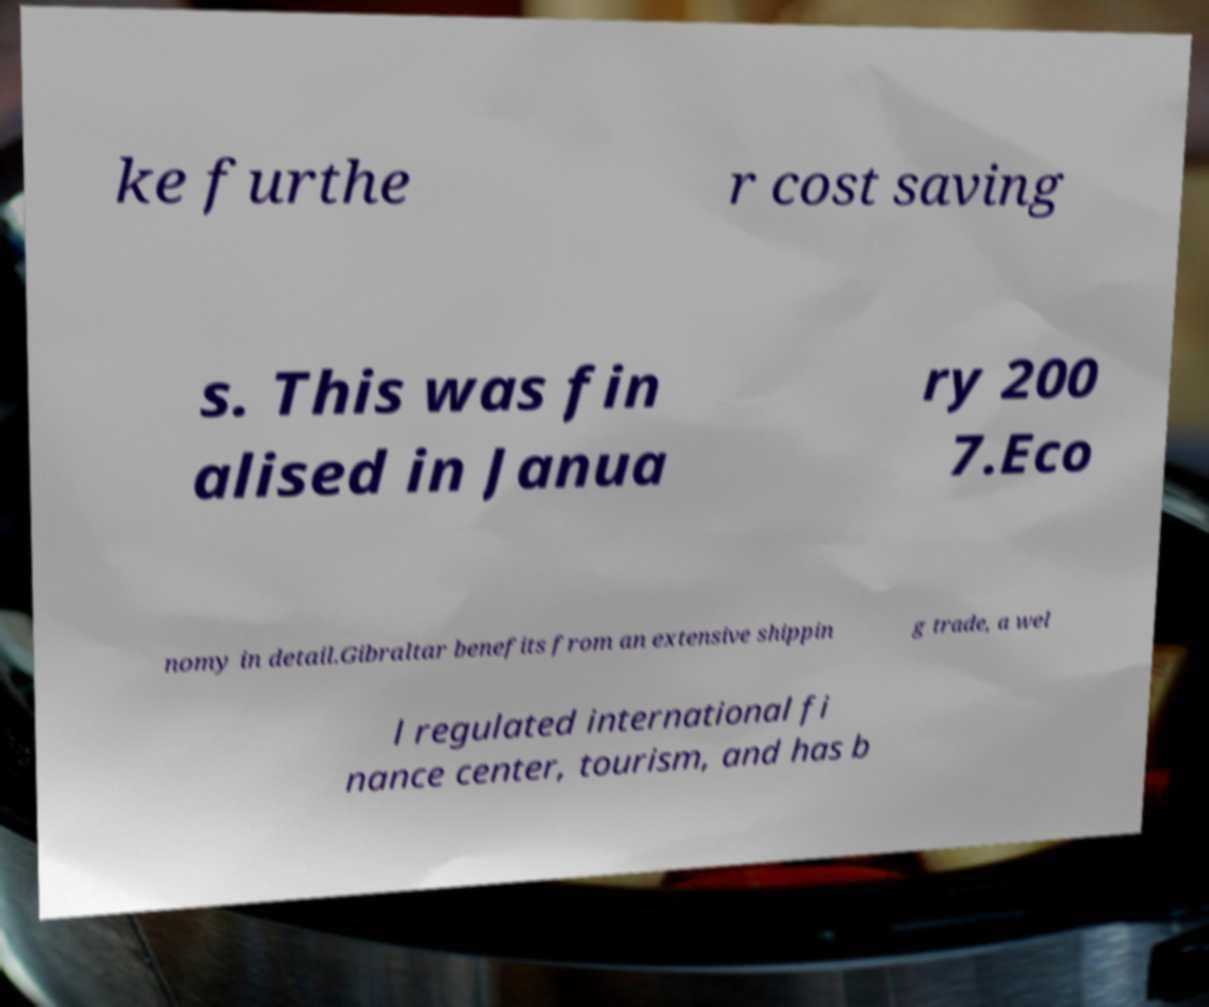What messages or text are displayed in this image? I need them in a readable, typed format. ke furthe r cost saving s. This was fin alised in Janua ry 200 7.Eco nomy in detail.Gibraltar benefits from an extensive shippin g trade, a wel l regulated international fi nance center, tourism, and has b 